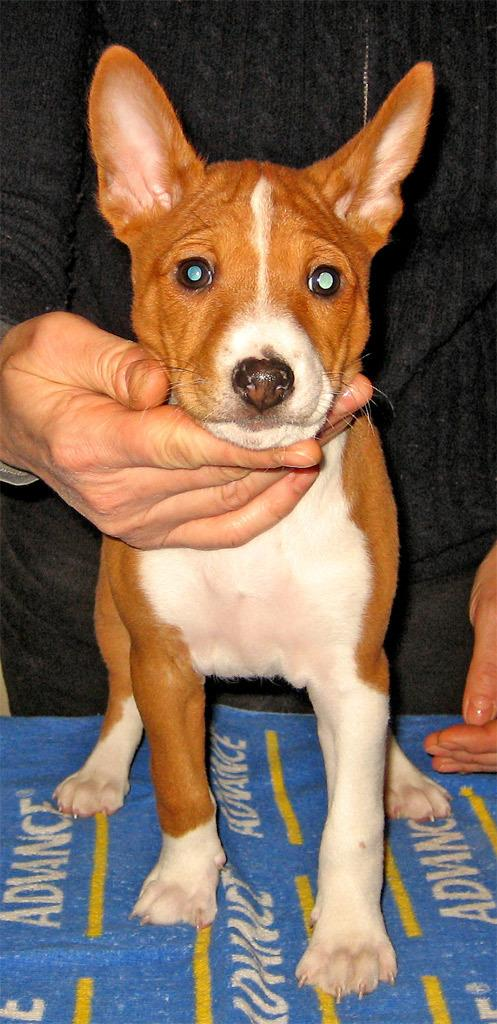What type of animal is in the image? There is a dog in the image. Can you describe the dog's appearance? The dog is brown and white in color. What is the person doing with the dog in the image? There is a human hand under the dog's neck, suggesting the person is petting or holding the dog. Is there anyone else visible in the image besides the dog? Yes, there is a person visible behind the dog. What type of dirt can be seen on the dog's paws in the image? There is no dirt visible on the dog's paws in the image. What is the dog's need for driving in the image? Dogs do not have the ability to drive, and there is no indication of driving in the image. 